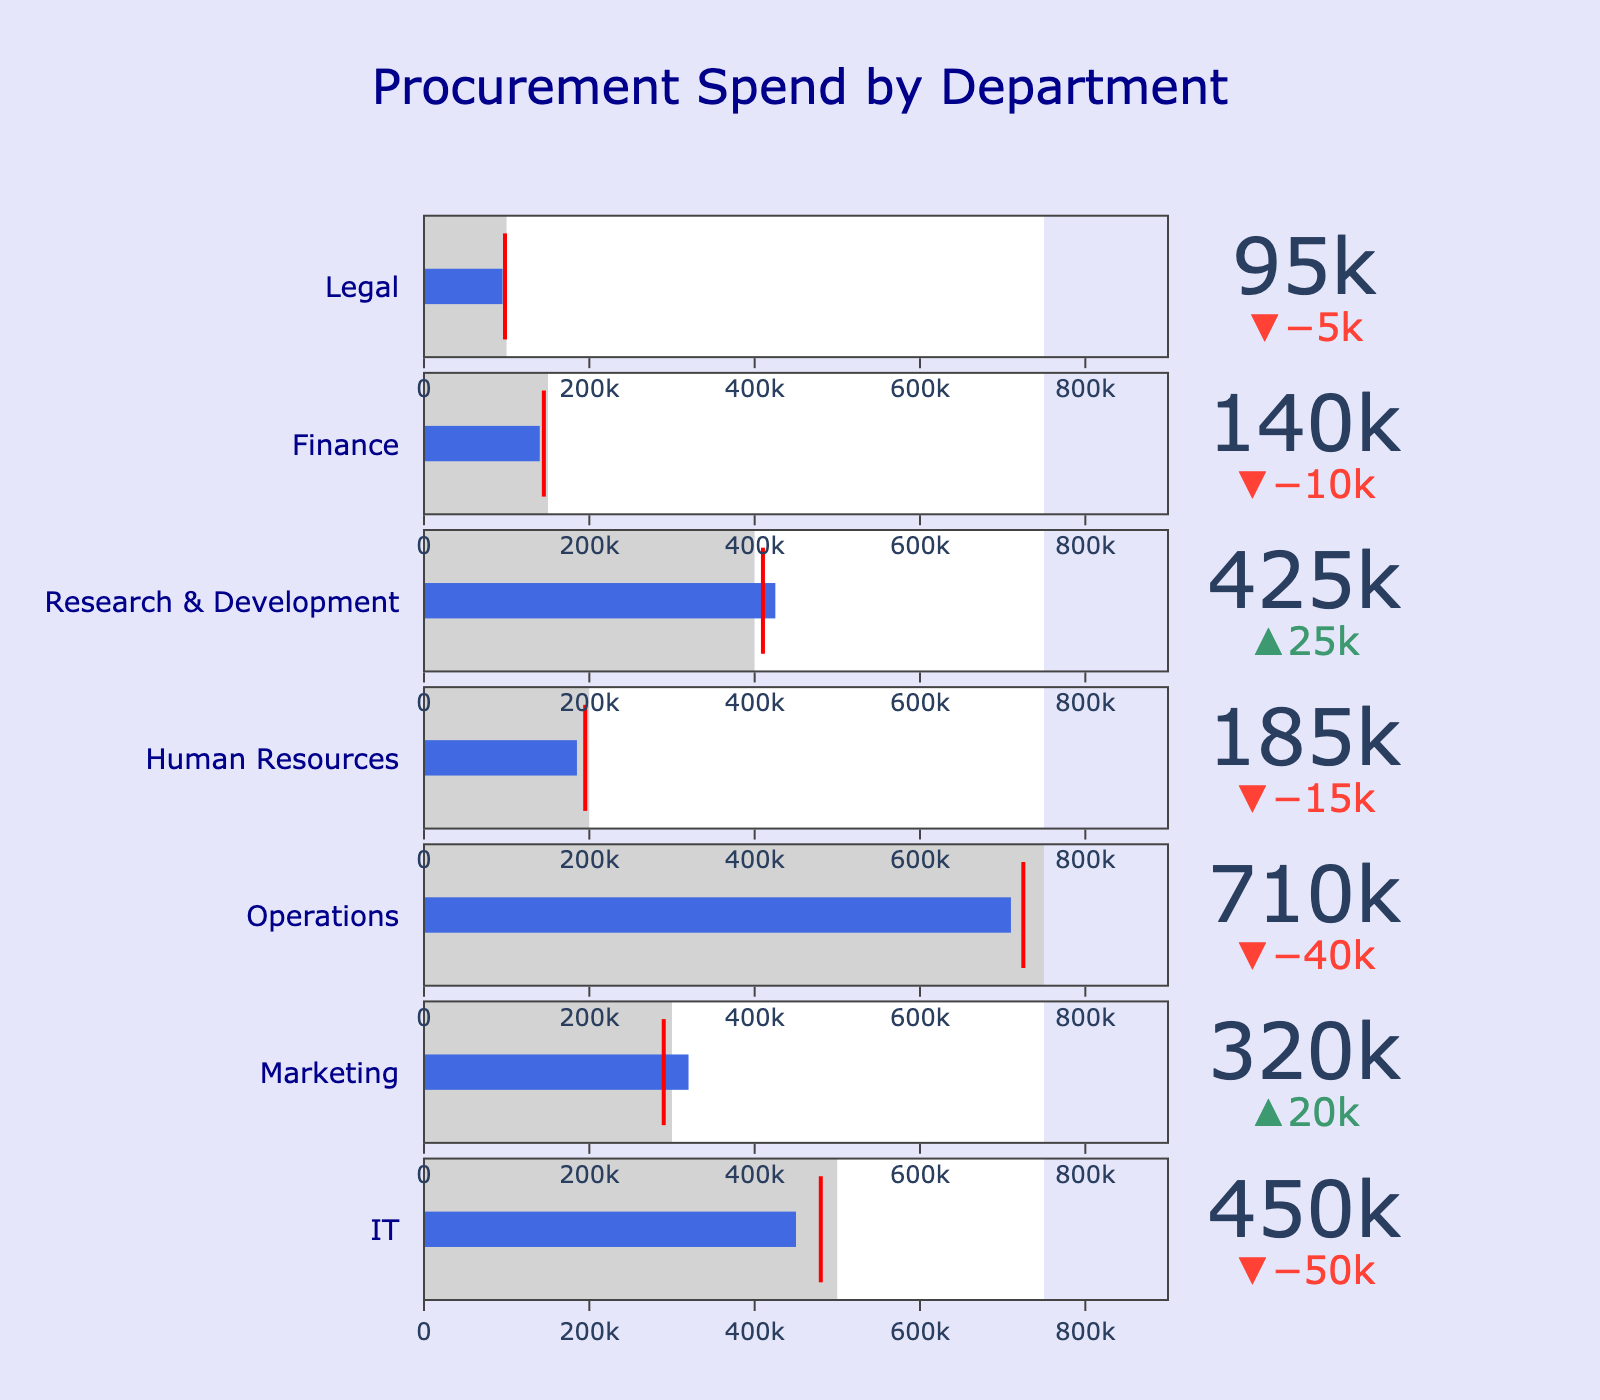How many departments are showcased in the figure? Count the number of distinct sections in the Bullet Chart, each representing a different department.
Answer: 7 Which department has the highest budgeted amount? Look at the bars indicating budgeted amounts and identify the department with the longest budget bar.
Answer: Operations Did the Marketing department exceed its budget? Compare the position of the actual expenditure bar with the budget bar for Marketing. The actual expenditure exceeds the budget if the bar extends beyond the budget bar.
Answer: Yes What is the target spend for IT? Find the target marker (a red line) in the IT department's bar. This represents the target spend.
Answer: 480,000 What is the difference between the actual and budgeted amounts for Human Resources? Subtract the actual expenditure from the budgeted amount for Human Resources.
Answer: 15,000 Is there any department where the actual spend is equal to the target spend? Compare the actual expenditure bar with the target marker for all departments. If they align exactly, the actual spend equals the target spend.
Answer: No Which department has spent over its budget and also exceeded its target? Identify any department where the actual expenditure bar exceeds both the budget bar and the target marker.
Answer: Research & Development What is the aggregate budgeted amount for IT, Marketing, and Finance? Sum the budgeted amounts for IT, Marketing, and Finance.
Answer: 950,000 Which department has the smallest difference between the actual and budgeted amounts? Calculate the difference between the actual and budgeted amounts for each department and identify the smallest one.
Answer: Legal How does the actual spend for Operations compare to its target spend? Compare the actual expenditure bar to the target marker for Operations. Determine if it is above, at, or below the target.
Answer: Below 